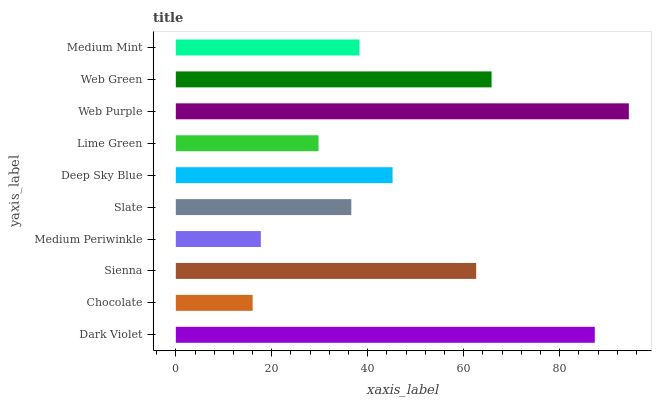Is Chocolate the minimum?
Answer yes or no. Yes. Is Web Purple the maximum?
Answer yes or no. Yes. Is Sienna the minimum?
Answer yes or no. No. Is Sienna the maximum?
Answer yes or no. No. Is Sienna greater than Chocolate?
Answer yes or no. Yes. Is Chocolate less than Sienna?
Answer yes or no. Yes. Is Chocolate greater than Sienna?
Answer yes or no. No. Is Sienna less than Chocolate?
Answer yes or no. No. Is Deep Sky Blue the high median?
Answer yes or no. Yes. Is Medium Mint the low median?
Answer yes or no. Yes. Is Slate the high median?
Answer yes or no. No. Is Dark Violet the low median?
Answer yes or no. No. 